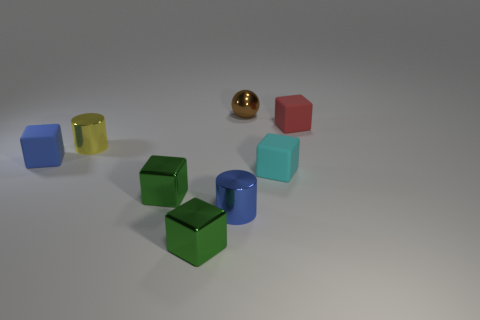What number of shiny things are both in front of the small red matte object and behind the cyan cube?
Keep it short and to the point. 1. What is the material of the small brown sphere that is behind the small cyan matte block?
Give a very brief answer. Metal. What size is the yellow thing that is made of the same material as the blue cylinder?
Your response must be concise. Small. There is a cube left of the small yellow metallic cylinder; does it have the same size as the red block to the right of the small yellow shiny cylinder?
Make the answer very short. Yes. What is the material of the yellow cylinder that is the same size as the brown object?
Offer a very short reply. Metal. There is a object that is both right of the small metallic sphere and in front of the tiny red thing; what is its material?
Offer a terse response. Rubber. Are there any tiny gray metallic balls?
Your answer should be very brief. No. There is a small shiny sphere; is it the same color as the small matte block that is behind the small blue block?
Ensure brevity in your answer.  No. Are there any other things that are the same shape as the small blue matte thing?
Make the answer very short. Yes. There is a small rubber thing that is on the left side of the metal thing behind the matte cube to the right of the cyan matte cube; what shape is it?
Ensure brevity in your answer.  Cube. 